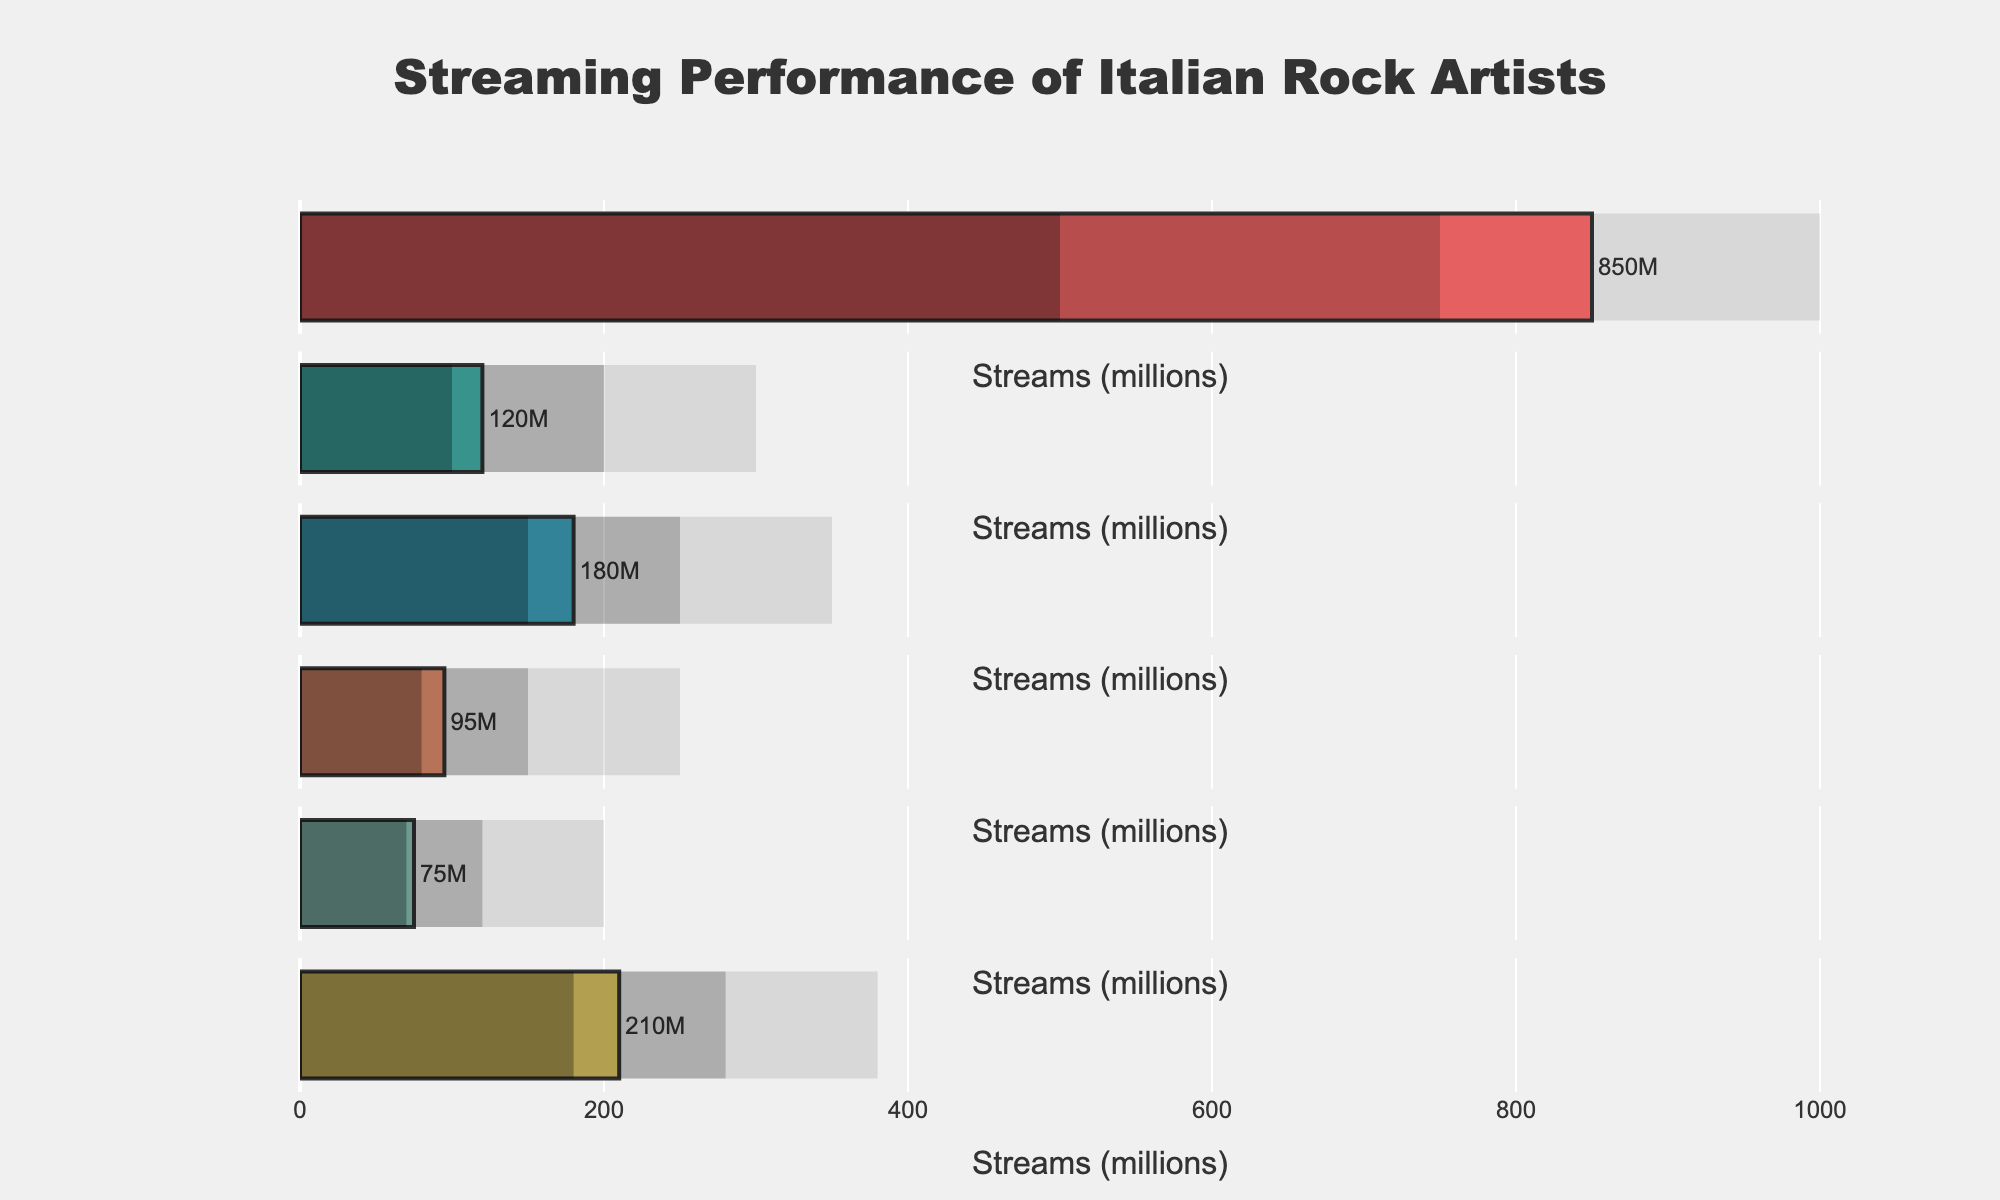What's the title of the chart? The title is prominently displayed at the top center of the chart. It reads "Streaming Performance of Italian Rock Artists".
Answer: Streaming Performance of Italian Rock Artists What color is used for Måneskin's bar in the chart? Måneskin's bar is colored with a distinct and bright shade. The exact color is a vibrant red.
Answer: Red Which artist has the lowest streaming number? By looking at the length of the bars, Afterhours has the shortest bar. Their streaming number is the lowest among all artists.
Answer: Afterhours What's the difference in streaming numbers between Måneskin and Litfiba? Måneskin has 850 million streams, and Litfiba has 120 million streams. The difference is 850 - 120 = 730 million.
Answer: 730 million How do Negrita's streaming numbers compare to the "Good" benchmark? Negrita's streaming number is 180 million, while the "Good" benchmark is 250 million. Negrita's streams are less than the "Good" benchmark.
Answer: Less than Which artist's streaming count meets or exceeds the 'Excellent' benchmark? The 'Excellent' benchmark is marked at different values. Only Måneskin's streaming number of 850 million meets and exceeds the 'Excellent' benchmark of 1000 million.
Answer: Måneskin What's the sum of streams for Subsonica and Afterhours? Subsonica has 95 million streams and Afterhours has 75 million streams. The sum is 95 + 75 = 170 million.
Answer: 170 million How many artists have streaming numbers higher than the "Average" benchmark? Måneskin (850 million), Litfiba (120 million), Negrita (180 million), Subsonica (95 million), Eiffel 65 (210 million) all have numbers above their respective "Average" benchmarks, counted as 5 out of the 6.
Answer: 5 artists 